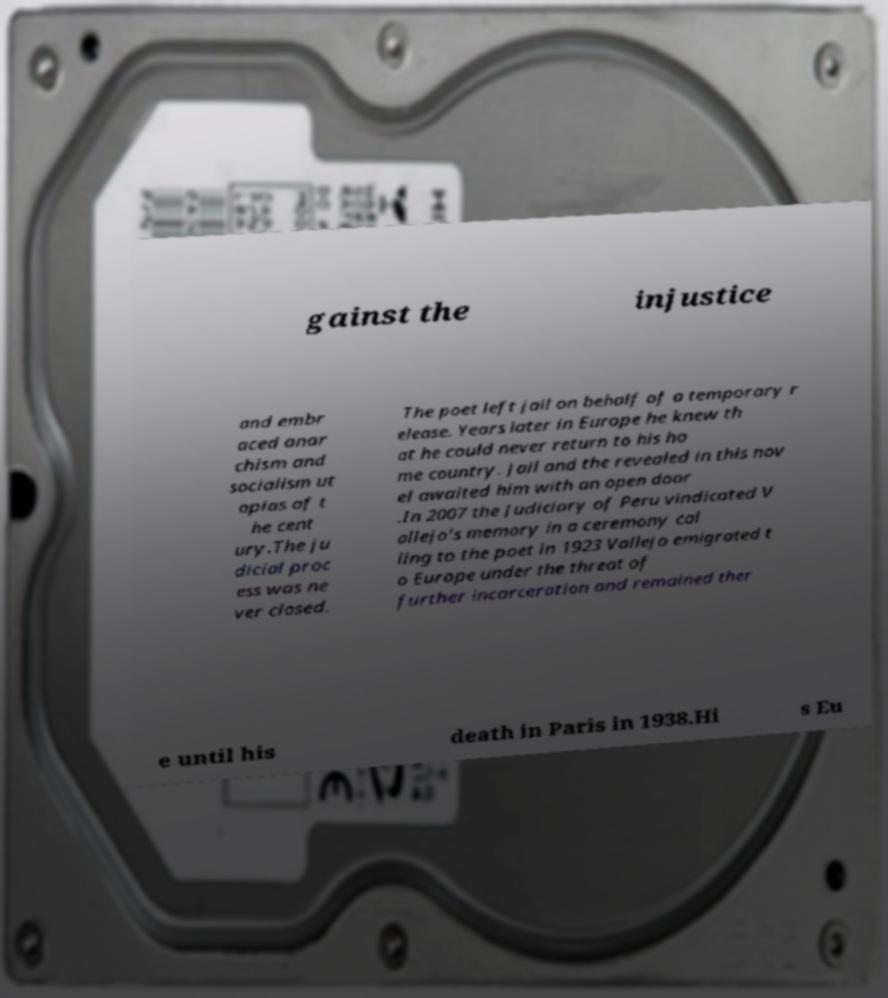I need the written content from this picture converted into text. Can you do that? gainst the injustice and embr aced anar chism and socialism ut opias of t he cent ury.The ju dicial proc ess was ne ver closed. The poet left jail on behalf of a temporary r elease. Years later in Europe he knew th at he could never return to his ho me country. Jail and the revealed in this nov el awaited him with an open door .In 2007 the Judiciary of Peru vindicated V allejo's memory in a ceremony cal ling to the poet in 1923 Vallejo emigrated t o Europe under the threat of further incarceration and remained ther e until his death in Paris in 1938.Hi s Eu 